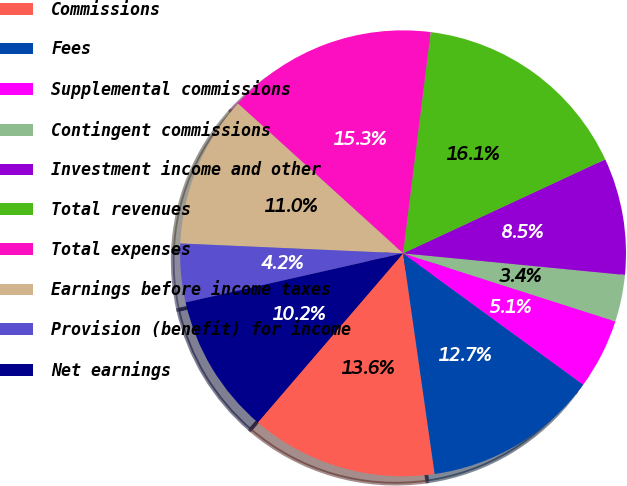Convert chart. <chart><loc_0><loc_0><loc_500><loc_500><pie_chart><fcel>Commissions<fcel>Fees<fcel>Supplemental commissions<fcel>Contingent commissions<fcel>Investment income and other<fcel>Total revenues<fcel>Total expenses<fcel>Earnings before income taxes<fcel>Provision (benefit) for income<fcel>Net earnings<nl><fcel>13.56%<fcel>12.71%<fcel>5.09%<fcel>3.39%<fcel>8.47%<fcel>16.1%<fcel>15.25%<fcel>11.02%<fcel>4.24%<fcel>10.17%<nl></chart> 